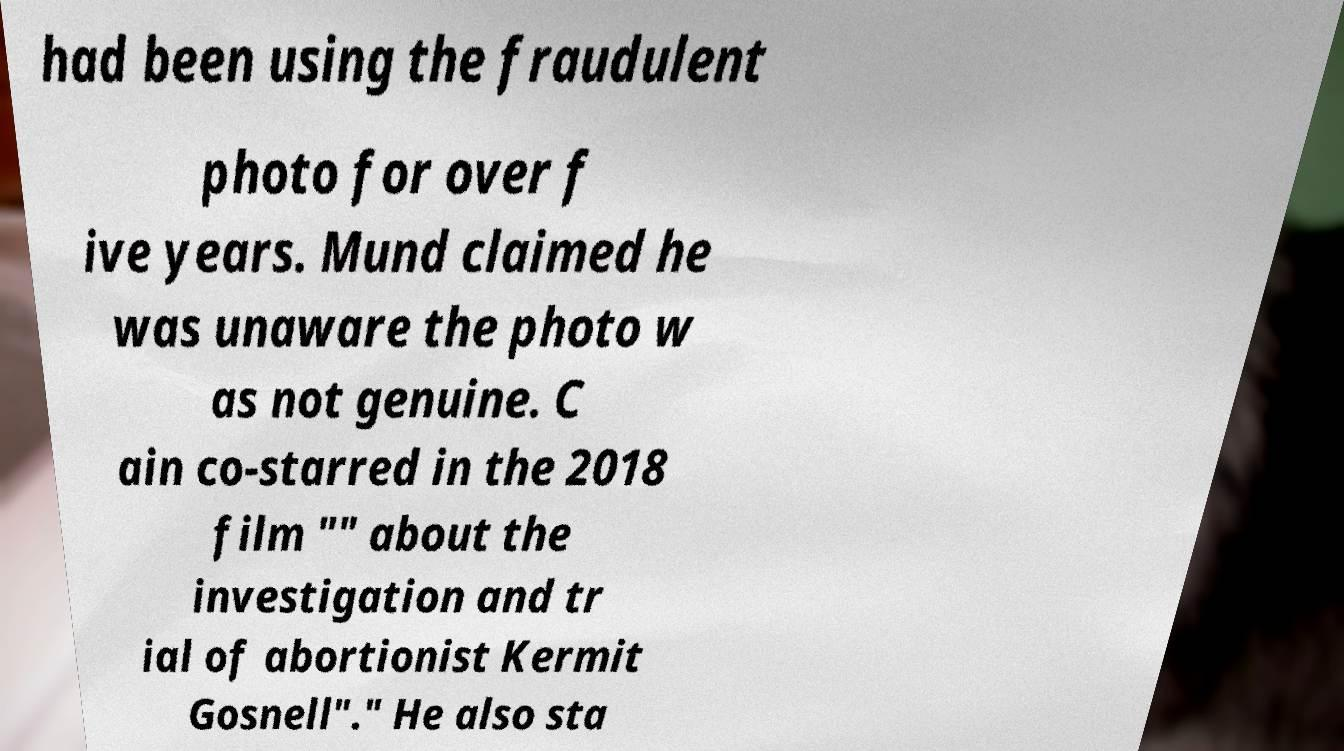Could you assist in decoding the text presented in this image and type it out clearly? had been using the fraudulent photo for over f ive years. Mund claimed he was unaware the photo w as not genuine. C ain co-starred in the 2018 film "" about the investigation and tr ial of abortionist Kermit Gosnell"." He also sta 